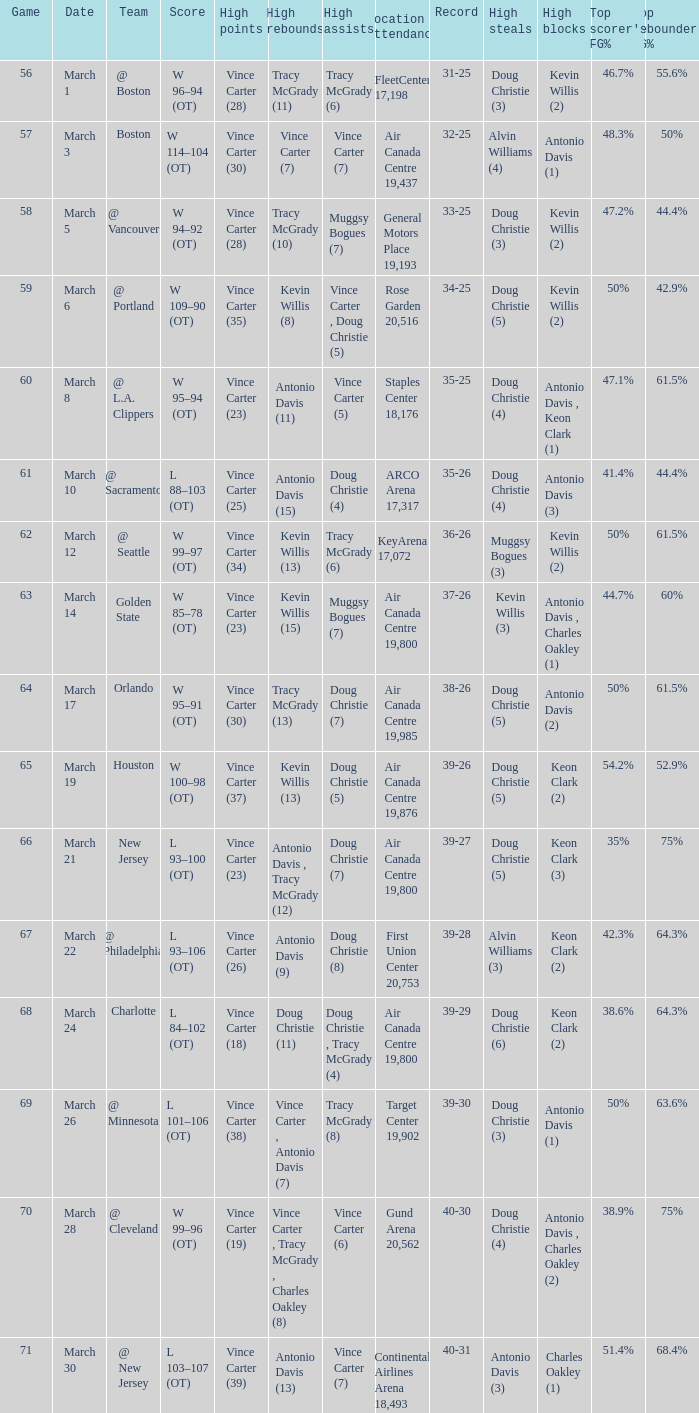How many people had the high assists @ minnesota? 1.0. 